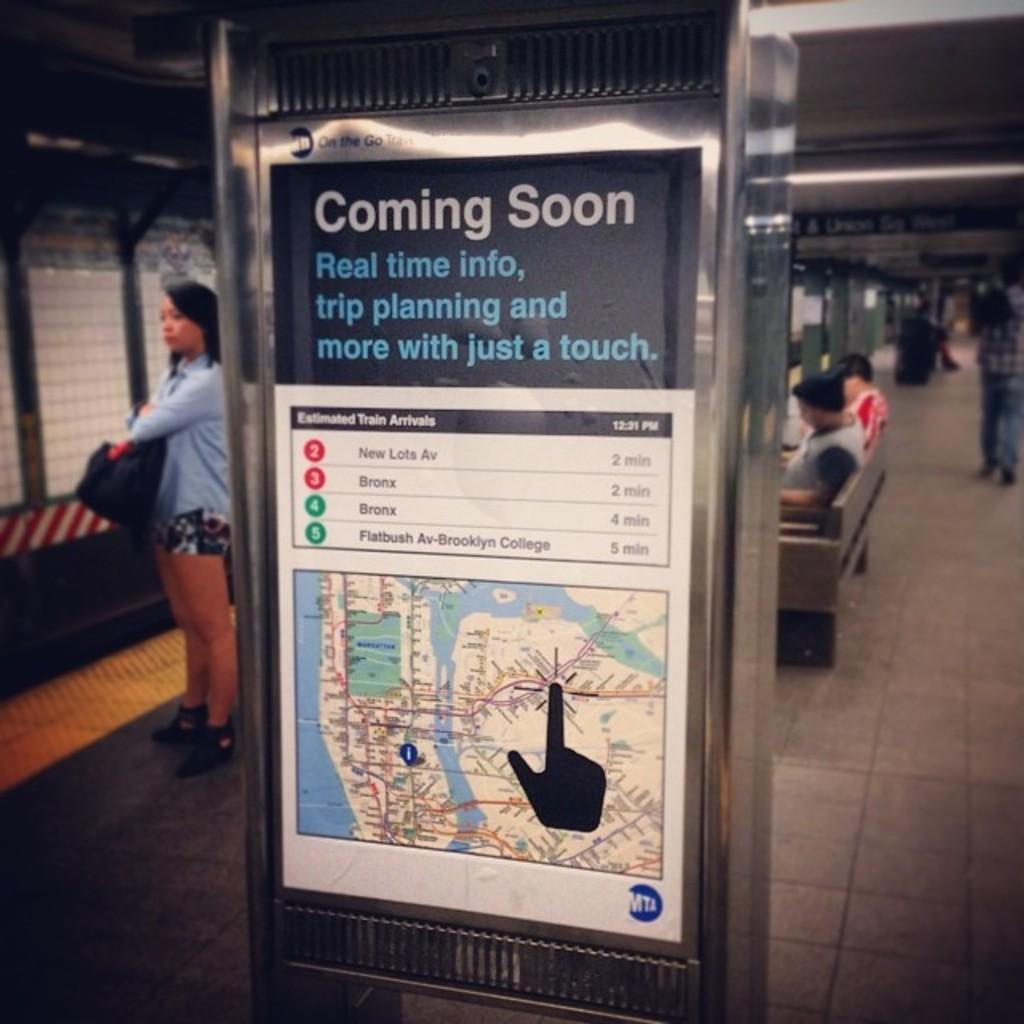Provide a one-sentence caption for the provided image. A large sign in a station that says Coming soon ,real time info and a map and more details . 